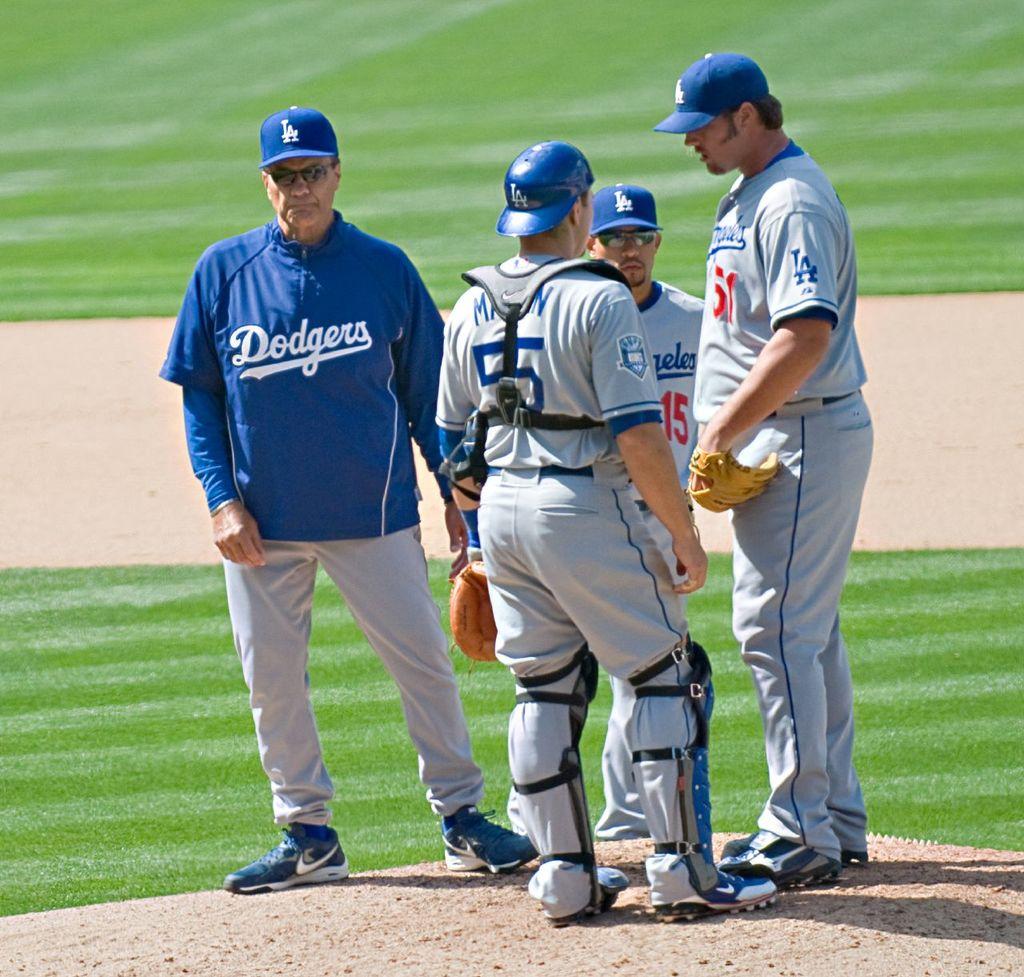What team is this?
Your answer should be compact. Dodgers. 